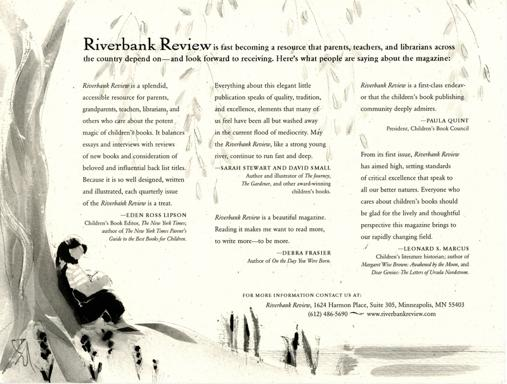How does the artwork in the image relate to the themes commonly explored in children's literature? The artwork here captures a moment of quiet introspection, a theme frequently encountered in children's literature where characters often embark on journeys of self-discovery and personal growth. The illustration's use of soft, monochromatic tones suggests a reflective atmosphere that encourages young readers to think about the world around them, much like the stories reviewed in the Riverbank Review aim to do. 